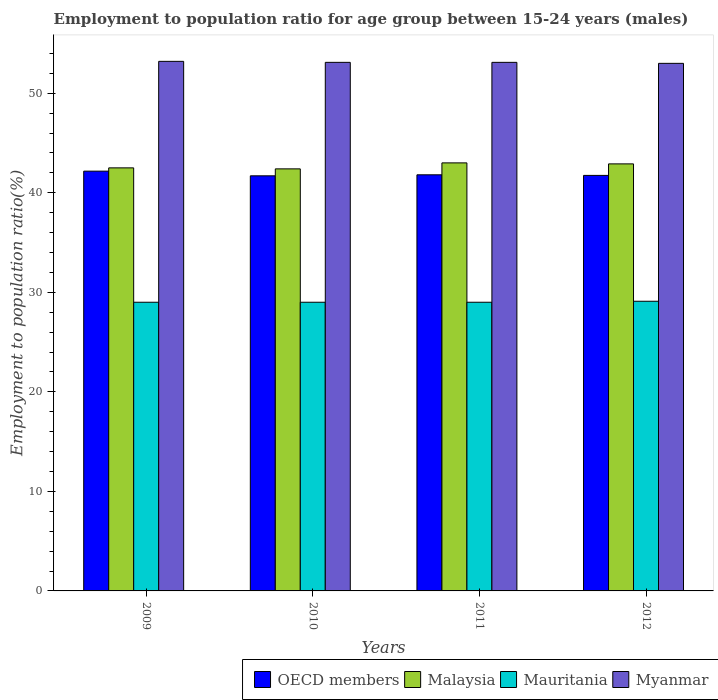How many groups of bars are there?
Provide a succinct answer. 4. Are the number of bars on each tick of the X-axis equal?
Offer a very short reply. Yes. How many bars are there on the 1st tick from the right?
Provide a succinct answer. 4. What is the employment to population ratio in Malaysia in 2012?
Keep it short and to the point. 42.9. Across all years, what is the maximum employment to population ratio in Malaysia?
Keep it short and to the point. 43. Across all years, what is the minimum employment to population ratio in Malaysia?
Offer a very short reply. 42.4. In which year was the employment to population ratio in Myanmar minimum?
Make the answer very short. 2012. What is the total employment to population ratio in Malaysia in the graph?
Offer a very short reply. 170.8. What is the difference between the employment to population ratio in Malaysia in 2011 and that in 2012?
Your response must be concise. 0.1. What is the difference between the employment to population ratio in OECD members in 2011 and the employment to population ratio in Mauritania in 2010?
Offer a terse response. 12.8. What is the average employment to population ratio in Myanmar per year?
Your answer should be very brief. 53.1. In the year 2011, what is the difference between the employment to population ratio in Malaysia and employment to population ratio in Myanmar?
Make the answer very short. -10.1. In how many years, is the employment to population ratio in Myanmar greater than 8 %?
Provide a succinct answer. 4. What is the ratio of the employment to population ratio in OECD members in 2009 to that in 2010?
Your answer should be compact. 1.01. Is the employment to population ratio in Myanmar in 2009 less than that in 2010?
Give a very brief answer. No. Is the difference between the employment to population ratio in Malaysia in 2010 and 2011 greater than the difference between the employment to population ratio in Myanmar in 2010 and 2011?
Provide a succinct answer. No. What is the difference between the highest and the second highest employment to population ratio in Myanmar?
Your answer should be compact. 0.1. What is the difference between the highest and the lowest employment to population ratio in Mauritania?
Your answer should be compact. 0.1. Is the sum of the employment to population ratio in Malaysia in 2009 and 2012 greater than the maximum employment to population ratio in Myanmar across all years?
Keep it short and to the point. Yes. What does the 2nd bar from the left in 2011 represents?
Offer a very short reply. Malaysia. Is it the case that in every year, the sum of the employment to population ratio in Mauritania and employment to population ratio in Myanmar is greater than the employment to population ratio in Malaysia?
Your answer should be compact. Yes. What is the difference between two consecutive major ticks on the Y-axis?
Offer a terse response. 10. Are the values on the major ticks of Y-axis written in scientific E-notation?
Make the answer very short. No. Does the graph contain any zero values?
Offer a terse response. No. What is the title of the graph?
Give a very brief answer. Employment to population ratio for age group between 15-24 years (males). Does "Gabon" appear as one of the legend labels in the graph?
Your response must be concise. No. What is the label or title of the X-axis?
Keep it short and to the point. Years. What is the Employment to population ratio(%) of OECD members in 2009?
Make the answer very short. 42.17. What is the Employment to population ratio(%) in Malaysia in 2009?
Your answer should be very brief. 42.5. What is the Employment to population ratio(%) of Myanmar in 2009?
Ensure brevity in your answer.  53.2. What is the Employment to population ratio(%) of OECD members in 2010?
Provide a succinct answer. 41.7. What is the Employment to population ratio(%) of Malaysia in 2010?
Your answer should be very brief. 42.4. What is the Employment to population ratio(%) in Myanmar in 2010?
Make the answer very short. 53.1. What is the Employment to population ratio(%) in OECD members in 2011?
Keep it short and to the point. 41.8. What is the Employment to population ratio(%) of Malaysia in 2011?
Make the answer very short. 43. What is the Employment to population ratio(%) of Myanmar in 2011?
Your answer should be compact. 53.1. What is the Employment to population ratio(%) in OECD members in 2012?
Provide a succinct answer. 41.74. What is the Employment to population ratio(%) in Malaysia in 2012?
Your answer should be compact. 42.9. What is the Employment to population ratio(%) in Mauritania in 2012?
Keep it short and to the point. 29.1. What is the Employment to population ratio(%) in Myanmar in 2012?
Ensure brevity in your answer.  53. Across all years, what is the maximum Employment to population ratio(%) of OECD members?
Provide a short and direct response. 42.17. Across all years, what is the maximum Employment to population ratio(%) in Malaysia?
Ensure brevity in your answer.  43. Across all years, what is the maximum Employment to population ratio(%) in Mauritania?
Give a very brief answer. 29.1. Across all years, what is the maximum Employment to population ratio(%) of Myanmar?
Your answer should be compact. 53.2. Across all years, what is the minimum Employment to population ratio(%) in OECD members?
Offer a terse response. 41.7. Across all years, what is the minimum Employment to population ratio(%) of Malaysia?
Your answer should be very brief. 42.4. Across all years, what is the minimum Employment to population ratio(%) of Myanmar?
Provide a short and direct response. 53. What is the total Employment to population ratio(%) in OECD members in the graph?
Offer a very short reply. 167.42. What is the total Employment to population ratio(%) of Malaysia in the graph?
Your response must be concise. 170.8. What is the total Employment to population ratio(%) of Mauritania in the graph?
Provide a succinct answer. 116.1. What is the total Employment to population ratio(%) in Myanmar in the graph?
Make the answer very short. 212.4. What is the difference between the Employment to population ratio(%) in OECD members in 2009 and that in 2010?
Provide a succinct answer. 0.47. What is the difference between the Employment to population ratio(%) in OECD members in 2009 and that in 2011?
Provide a short and direct response. 0.37. What is the difference between the Employment to population ratio(%) of Malaysia in 2009 and that in 2011?
Offer a very short reply. -0.5. What is the difference between the Employment to population ratio(%) of Mauritania in 2009 and that in 2011?
Provide a short and direct response. 0. What is the difference between the Employment to population ratio(%) in Myanmar in 2009 and that in 2011?
Provide a succinct answer. 0.1. What is the difference between the Employment to population ratio(%) of OECD members in 2009 and that in 2012?
Your answer should be very brief. 0.43. What is the difference between the Employment to population ratio(%) of Malaysia in 2009 and that in 2012?
Your answer should be very brief. -0.4. What is the difference between the Employment to population ratio(%) of Mauritania in 2009 and that in 2012?
Your answer should be compact. -0.1. What is the difference between the Employment to population ratio(%) of OECD members in 2010 and that in 2011?
Provide a succinct answer. -0.1. What is the difference between the Employment to population ratio(%) in OECD members in 2010 and that in 2012?
Give a very brief answer. -0.04. What is the difference between the Employment to population ratio(%) of Mauritania in 2010 and that in 2012?
Your response must be concise. -0.1. What is the difference between the Employment to population ratio(%) of OECD members in 2011 and that in 2012?
Provide a short and direct response. 0.06. What is the difference between the Employment to population ratio(%) of Mauritania in 2011 and that in 2012?
Give a very brief answer. -0.1. What is the difference between the Employment to population ratio(%) of OECD members in 2009 and the Employment to population ratio(%) of Malaysia in 2010?
Provide a short and direct response. -0.23. What is the difference between the Employment to population ratio(%) of OECD members in 2009 and the Employment to population ratio(%) of Mauritania in 2010?
Make the answer very short. 13.17. What is the difference between the Employment to population ratio(%) of OECD members in 2009 and the Employment to population ratio(%) of Myanmar in 2010?
Your answer should be very brief. -10.93. What is the difference between the Employment to population ratio(%) in Mauritania in 2009 and the Employment to population ratio(%) in Myanmar in 2010?
Make the answer very short. -24.1. What is the difference between the Employment to population ratio(%) in OECD members in 2009 and the Employment to population ratio(%) in Malaysia in 2011?
Give a very brief answer. -0.83. What is the difference between the Employment to population ratio(%) in OECD members in 2009 and the Employment to population ratio(%) in Mauritania in 2011?
Offer a terse response. 13.17. What is the difference between the Employment to population ratio(%) in OECD members in 2009 and the Employment to population ratio(%) in Myanmar in 2011?
Keep it short and to the point. -10.93. What is the difference between the Employment to population ratio(%) in Mauritania in 2009 and the Employment to population ratio(%) in Myanmar in 2011?
Offer a terse response. -24.1. What is the difference between the Employment to population ratio(%) in OECD members in 2009 and the Employment to population ratio(%) in Malaysia in 2012?
Your answer should be very brief. -0.73. What is the difference between the Employment to population ratio(%) of OECD members in 2009 and the Employment to population ratio(%) of Mauritania in 2012?
Your answer should be very brief. 13.07. What is the difference between the Employment to population ratio(%) in OECD members in 2009 and the Employment to population ratio(%) in Myanmar in 2012?
Your response must be concise. -10.83. What is the difference between the Employment to population ratio(%) in Mauritania in 2009 and the Employment to population ratio(%) in Myanmar in 2012?
Your answer should be compact. -24. What is the difference between the Employment to population ratio(%) of OECD members in 2010 and the Employment to population ratio(%) of Malaysia in 2011?
Give a very brief answer. -1.3. What is the difference between the Employment to population ratio(%) of OECD members in 2010 and the Employment to population ratio(%) of Mauritania in 2011?
Offer a terse response. 12.7. What is the difference between the Employment to population ratio(%) of OECD members in 2010 and the Employment to population ratio(%) of Myanmar in 2011?
Provide a succinct answer. -11.4. What is the difference between the Employment to population ratio(%) of Malaysia in 2010 and the Employment to population ratio(%) of Mauritania in 2011?
Provide a succinct answer. 13.4. What is the difference between the Employment to population ratio(%) of Mauritania in 2010 and the Employment to population ratio(%) of Myanmar in 2011?
Provide a succinct answer. -24.1. What is the difference between the Employment to population ratio(%) of OECD members in 2010 and the Employment to population ratio(%) of Malaysia in 2012?
Provide a succinct answer. -1.2. What is the difference between the Employment to population ratio(%) in OECD members in 2010 and the Employment to population ratio(%) in Mauritania in 2012?
Your response must be concise. 12.6. What is the difference between the Employment to population ratio(%) of OECD members in 2010 and the Employment to population ratio(%) of Myanmar in 2012?
Your answer should be compact. -11.3. What is the difference between the Employment to population ratio(%) of Malaysia in 2010 and the Employment to population ratio(%) of Mauritania in 2012?
Your answer should be compact. 13.3. What is the difference between the Employment to population ratio(%) of Malaysia in 2010 and the Employment to population ratio(%) of Myanmar in 2012?
Make the answer very short. -10.6. What is the difference between the Employment to population ratio(%) in OECD members in 2011 and the Employment to population ratio(%) in Malaysia in 2012?
Your answer should be compact. -1.1. What is the difference between the Employment to population ratio(%) of OECD members in 2011 and the Employment to population ratio(%) of Mauritania in 2012?
Ensure brevity in your answer.  12.7. What is the difference between the Employment to population ratio(%) in OECD members in 2011 and the Employment to population ratio(%) in Myanmar in 2012?
Keep it short and to the point. -11.2. What is the difference between the Employment to population ratio(%) of Malaysia in 2011 and the Employment to population ratio(%) of Myanmar in 2012?
Offer a terse response. -10. What is the average Employment to population ratio(%) in OECD members per year?
Offer a very short reply. 41.85. What is the average Employment to population ratio(%) in Malaysia per year?
Your answer should be very brief. 42.7. What is the average Employment to population ratio(%) of Mauritania per year?
Offer a very short reply. 29.02. What is the average Employment to population ratio(%) of Myanmar per year?
Ensure brevity in your answer.  53.1. In the year 2009, what is the difference between the Employment to population ratio(%) in OECD members and Employment to population ratio(%) in Malaysia?
Your response must be concise. -0.33. In the year 2009, what is the difference between the Employment to population ratio(%) of OECD members and Employment to population ratio(%) of Mauritania?
Your answer should be very brief. 13.17. In the year 2009, what is the difference between the Employment to population ratio(%) of OECD members and Employment to population ratio(%) of Myanmar?
Make the answer very short. -11.03. In the year 2009, what is the difference between the Employment to population ratio(%) of Malaysia and Employment to population ratio(%) of Mauritania?
Keep it short and to the point. 13.5. In the year 2009, what is the difference between the Employment to population ratio(%) of Mauritania and Employment to population ratio(%) of Myanmar?
Ensure brevity in your answer.  -24.2. In the year 2010, what is the difference between the Employment to population ratio(%) in OECD members and Employment to population ratio(%) in Malaysia?
Provide a short and direct response. -0.7. In the year 2010, what is the difference between the Employment to population ratio(%) in OECD members and Employment to population ratio(%) in Mauritania?
Ensure brevity in your answer.  12.7. In the year 2010, what is the difference between the Employment to population ratio(%) in OECD members and Employment to population ratio(%) in Myanmar?
Give a very brief answer. -11.4. In the year 2010, what is the difference between the Employment to population ratio(%) in Mauritania and Employment to population ratio(%) in Myanmar?
Make the answer very short. -24.1. In the year 2011, what is the difference between the Employment to population ratio(%) in OECD members and Employment to population ratio(%) in Malaysia?
Make the answer very short. -1.2. In the year 2011, what is the difference between the Employment to population ratio(%) of OECD members and Employment to population ratio(%) of Mauritania?
Give a very brief answer. 12.8. In the year 2011, what is the difference between the Employment to population ratio(%) of OECD members and Employment to population ratio(%) of Myanmar?
Your answer should be very brief. -11.3. In the year 2011, what is the difference between the Employment to population ratio(%) of Mauritania and Employment to population ratio(%) of Myanmar?
Provide a short and direct response. -24.1. In the year 2012, what is the difference between the Employment to population ratio(%) of OECD members and Employment to population ratio(%) of Malaysia?
Give a very brief answer. -1.16. In the year 2012, what is the difference between the Employment to population ratio(%) in OECD members and Employment to population ratio(%) in Mauritania?
Give a very brief answer. 12.64. In the year 2012, what is the difference between the Employment to population ratio(%) of OECD members and Employment to population ratio(%) of Myanmar?
Offer a terse response. -11.26. In the year 2012, what is the difference between the Employment to population ratio(%) in Malaysia and Employment to population ratio(%) in Mauritania?
Offer a terse response. 13.8. In the year 2012, what is the difference between the Employment to population ratio(%) in Mauritania and Employment to population ratio(%) in Myanmar?
Offer a very short reply. -23.9. What is the ratio of the Employment to population ratio(%) of OECD members in 2009 to that in 2010?
Your response must be concise. 1.01. What is the ratio of the Employment to population ratio(%) in Malaysia in 2009 to that in 2010?
Ensure brevity in your answer.  1. What is the ratio of the Employment to population ratio(%) in Mauritania in 2009 to that in 2010?
Keep it short and to the point. 1. What is the ratio of the Employment to population ratio(%) of OECD members in 2009 to that in 2011?
Keep it short and to the point. 1.01. What is the ratio of the Employment to population ratio(%) in Malaysia in 2009 to that in 2011?
Keep it short and to the point. 0.99. What is the ratio of the Employment to population ratio(%) in OECD members in 2009 to that in 2012?
Offer a very short reply. 1.01. What is the ratio of the Employment to population ratio(%) of Mauritania in 2009 to that in 2012?
Ensure brevity in your answer.  1. What is the ratio of the Employment to population ratio(%) of Myanmar in 2009 to that in 2012?
Offer a very short reply. 1. What is the ratio of the Employment to population ratio(%) in OECD members in 2010 to that in 2011?
Ensure brevity in your answer.  1. What is the ratio of the Employment to population ratio(%) in Mauritania in 2010 to that in 2011?
Offer a terse response. 1. What is the ratio of the Employment to population ratio(%) in Malaysia in 2010 to that in 2012?
Ensure brevity in your answer.  0.99. What is the ratio of the Employment to population ratio(%) in Mauritania in 2010 to that in 2012?
Your answer should be very brief. 1. What is the ratio of the Employment to population ratio(%) of Myanmar in 2010 to that in 2012?
Give a very brief answer. 1. What is the ratio of the Employment to population ratio(%) in Mauritania in 2011 to that in 2012?
Your answer should be very brief. 1. What is the ratio of the Employment to population ratio(%) of Myanmar in 2011 to that in 2012?
Keep it short and to the point. 1. What is the difference between the highest and the second highest Employment to population ratio(%) in OECD members?
Provide a succinct answer. 0.37. What is the difference between the highest and the second highest Employment to population ratio(%) in Mauritania?
Provide a short and direct response. 0.1. What is the difference between the highest and the lowest Employment to population ratio(%) of OECD members?
Ensure brevity in your answer.  0.47. What is the difference between the highest and the lowest Employment to population ratio(%) of Mauritania?
Your answer should be compact. 0.1. 